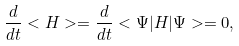Convert formula to latex. <formula><loc_0><loc_0><loc_500><loc_500>\frac { d } { d t } < H > = \frac { d } { d t } < \Psi | H | \Psi > = 0 ,</formula> 